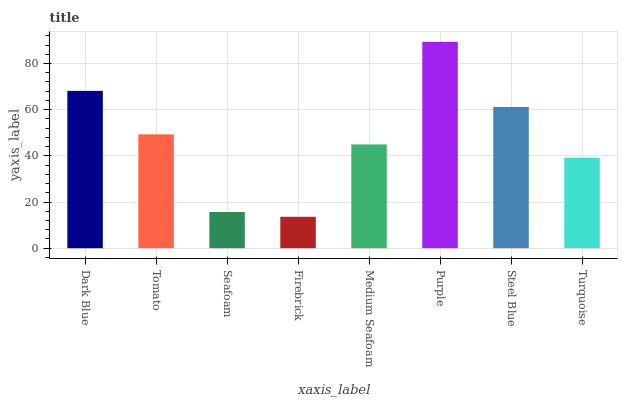Is Tomato the minimum?
Answer yes or no. No. Is Tomato the maximum?
Answer yes or no. No. Is Dark Blue greater than Tomato?
Answer yes or no. Yes. Is Tomato less than Dark Blue?
Answer yes or no. Yes. Is Tomato greater than Dark Blue?
Answer yes or no. No. Is Dark Blue less than Tomato?
Answer yes or no. No. Is Tomato the high median?
Answer yes or no. Yes. Is Medium Seafoam the low median?
Answer yes or no. Yes. Is Turquoise the high median?
Answer yes or no. No. Is Dark Blue the low median?
Answer yes or no. No. 